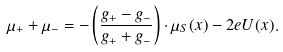<formula> <loc_0><loc_0><loc_500><loc_500>\mu _ { + } + \mu _ { - } = - \left ( \frac { g _ { + } - g _ { - } } { g _ { + } + g _ { - } } \right ) \cdot \mu _ { S } ( x ) - 2 e U ( x ) .</formula> 